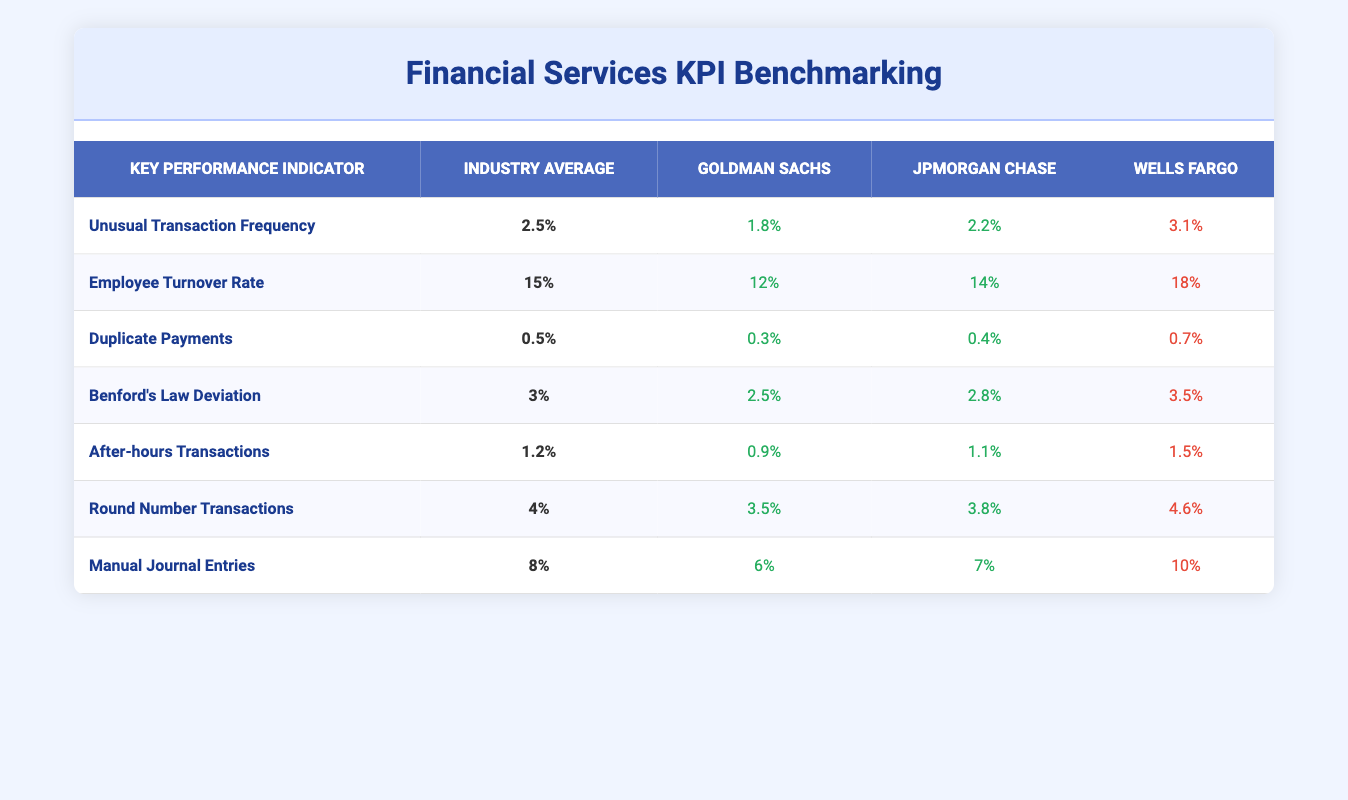What is the Unusual Transaction Frequency for Goldman Sachs? According to the table, Goldman Sachs' Unusual Transaction Frequency is listed as 1.8%.
Answer: 1.8% Which company has the highest Employee Turnover Rate? By comparing the Employee Turnover Rates, Wells Fargo has the highest rate at 18%.
Answer: Wells Fargo What is the average Duplicate Payments across the three companies? The Duplicate Payments for each company are 0.3%, 0.4%, and 0.7%. To find the average, add these values: (0.3 + 0.4 + 0.7) = 1.4%, then divide by 3, which gives an average of 1.4%/3 = 0.4667%, or approximately 0.47%.
Answer: 0.47% Is JPMorgan Chase’s Benford's Law Deviation below or above the industry average? The industry average for Benford's Law Deviation is 3%. JPMorgan Chase's value is 2.8%, which is below the average.
Answer: Below Which company shows the least compliance regarding After-hours Transactions? Comparing the After-hours Transactions values, Goldman Sachs has the lowest at 0.9%, indicating less compliance in this area.
Answer: Goldman Sachs How much lower is Wells Fargo’s Manual Journal Entries compared to the industry average? The industry average for Manual Journal Entries is 8%, and Wells Fargo's value is 10%. Therefore, it is higher than the average, so to find how much lower the industry standard would be compared to Wells Fargo's: 10%-8% = 2%.
Answer: 2% What percentage of Round Number Transactions does JPMorgan Chase have compared to the industry average? The industry average for Round Number Transactions is 4%, and JPMorgan Chase has 3.8%. This means that JPMorgan Chase's percentage is below the average by calculating the difference: 4% - 3.8% = 0.2%.
Answer: 0.2% Which company's Unusual Transaction Frequency is closest to the industry average? The Unusual Transaction Frequency values are 1.8% for Goldman Sachs, 2.2% for JPMorgan Chase, and 3.1% for Wells Fargo. Among these, JPMorgan Chase's 2.2% is closest to the industry average of 2.5%.
Answer: JPMorgan Chase What can be inferred about Goldman Sachs from its Duplicate Payments? Goldman Sachs' Duplicate Payments are at 0.3%, which is significantly lower than the industry average of 0.5%, indicating better control over this KPI.
Answer: Better control 